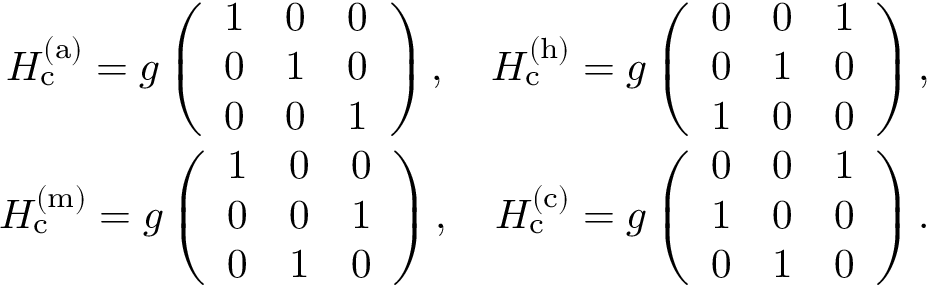<formula> <loc_0><loc_0><loc_500><loc_500>\begin{array} { r l r } & { H _ { c } ^ { ( a ) } = g \left ( \begin{array} { c c c } { 1 } & { 0 } & { 0 } \\ { 0 } & { 1 } & { 0 } \\ { 0 } & { 0 } & { 1 } \end{array} \right ) , \quad H _ { c } ^ { ( h ) } = g \left ( \begin{array} { c c c } { 0 } & { 0 } & { 1 } \\ { 0 } & { 1 } & { 0 } \\ { 1 } & { 0 } & { 0 } \end{array} \right ) , } \\ & { H _ { c } ^ { ( m ) } = g \left ( \begin{array} { c c c } { 1 } & { 0 } & { 0 } \\ { 0 } & { 0 } & { 1 } \\ { 0 } & { 1 } & { 0 } \end{array} \right ) , \quad H _ { c } ^ { ( c ) } = g \left ( \begin{array} { c c c } { 0 } & { 0 } & { 1 } \\ { 1 } & { 0 } & { 0 } \\ { 0 } & { 1 } & { 0 } \end{array} \right ) . } \end{array}</formula> 